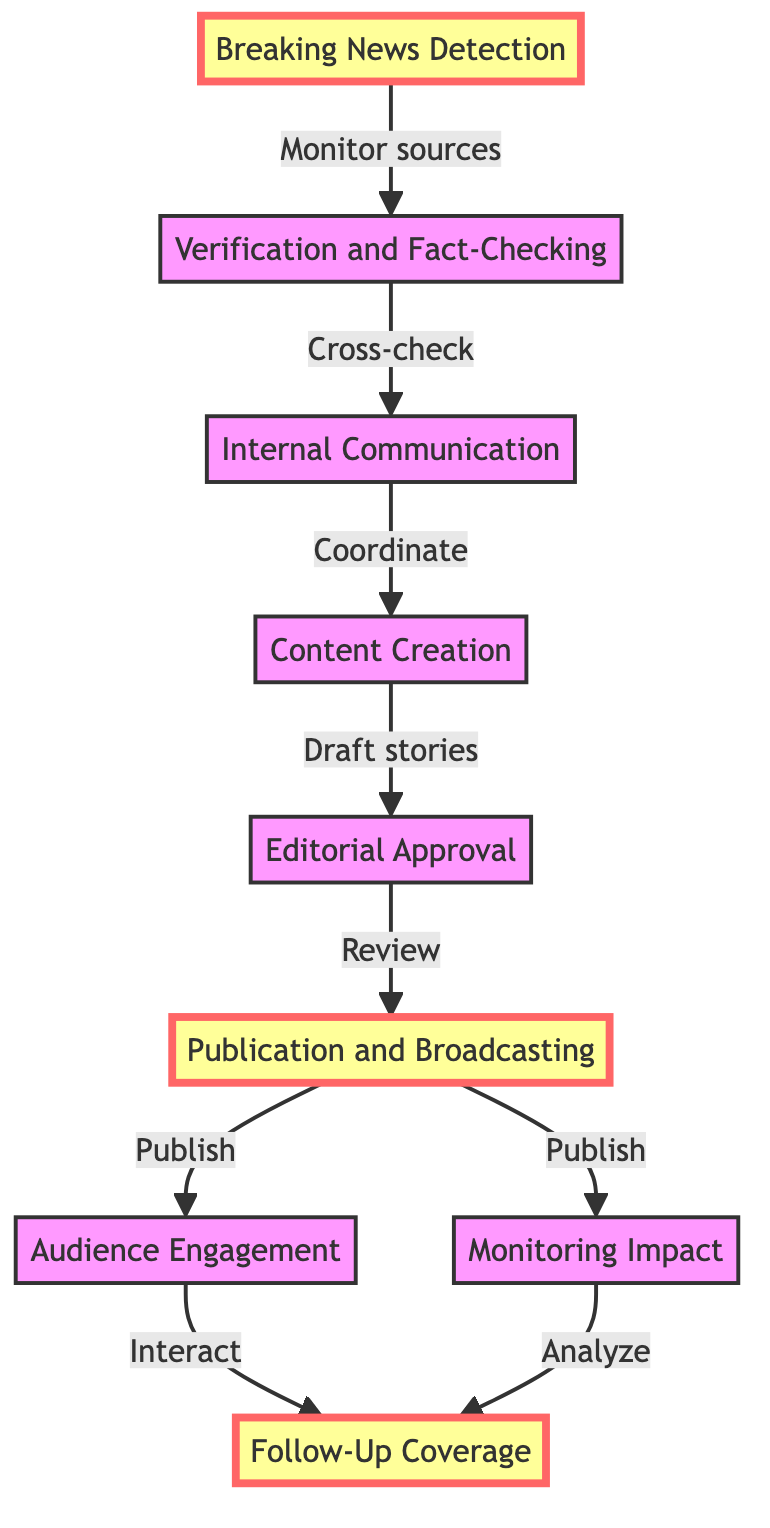What is the first step in the crisis management process? The first step, labeled as "Breaking News Detection," involves monitoring sources like social media and news agencies to identify breaking news.
Answer: Breaking News Detection How many total steps are there in the diagram? There are nine steps in the diagram, each representing a key part of the crisis management process.
Answer: Nine What follows after "Content Creation"? The step that follows "Content Creation" is "Editorial Approval," which involves reviewing the content for accuracy and clarity.
Answer: Editorial Approval Which step focuses on interaction with the audience? The step that focuses on interaction with the audience is "Audience Engagement." This stage involves responding to audience comments and providing live updates.
Answer: Audience Engagement What are the two outcomes following "Publication and Broadcasting"? The two outcomes after "Publication and Broadcasting" are "Audience Engagement" and "Monitoring Impact," which involve engaging with the audience and analyzing how they respond to the published content.
Answer: Audience Engagement and Monitoring Impact What do the yellow-highlighted steps indicate? The yellow-highlighted steps denote critical parts of the crisis management process, specifically "Breaking News Detection," "Publication and Broadcasting," and "Follow-Up Coverage," emphasizing their significance.
Answer: Critical steps What type of communication is emphasized during the "Internal Communication" stage? The "Internal Communication" stage emphasizes coordination among the editorial team, reporters, and fact-checkers, focusing on team collaboration.
Answer: Coordination Which step requires cross-checking information? The step that requires cross-checking information is "Verification and Fact-Checking," where information is validated using reliable sources and interviews.
Answer: Verification and Fact-Checking What is the purpose of "Follow-Up Coverage"? The purpose of "Follow-Up Coverage" is to provide updates, corrections, or in-depth analysis as more information becomes available, ensuring accurate reporting throughout the crisis.
Answer: Updates and analysis 